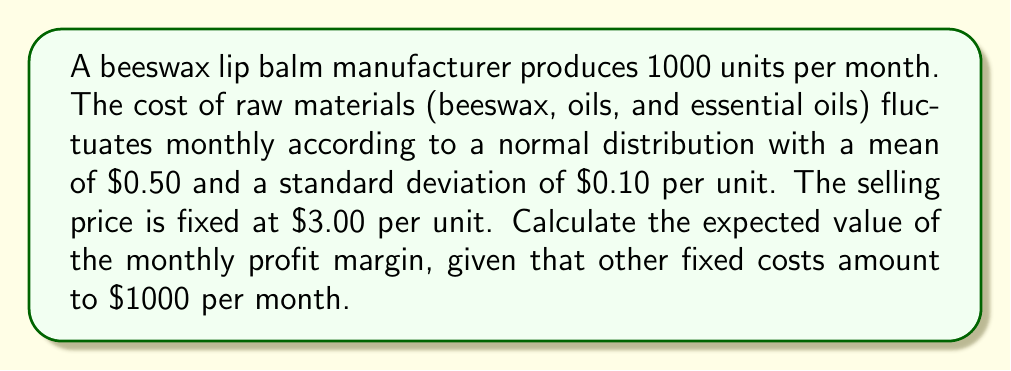Show me your answer to this math problem. Let's approach this step-by-step:

1) First, we need to define our variables:
   Let $X$ be the random variable representing the cost of raw materials per unit.
   $X \sim N(\mu = 0.50, \sigma = 0.10)$

2) The profit per unit is the selling price minus the cost of raw materials:
   Profit per unit = $3.00 - X$

3) For 1000 units, the total profit before fixed costs is:
   Total profit before fixed costs = $1000(3.00 - X)$

4) Subtracting the fixed costs:
   Total profit = $1000(3.00 - X) - 1000$

5) The expected value of the total profit is:
   $E[\text{Total profit}] = E[1000(3.00 - X) - 1000]$
   $= 1000E[3.00 - X] - 1000$
   $= 1000(3.00 - E[X]) - 1000$

6) We know that $E[X] = \mu = 0.50$, so:
   $E[\text{Total profit}] = 1000(3.00 - 0.50) - 1000$
   $= 1000(2.50) - 1000$
   $= 2500 - 1000$
   $= 1500$

7) The profit margin is the profit divided by the revenue:
   Expected profit margin = $\frac{E[\text{Total profit}]}{\text{Total revenue}}$
   $= \frac{1500}{1000 \times 3.00} = \frac{1500}{3000} = 0.5$

Therefore, the expected value of the monthly profit margin is 0.5 or 50%.
Answer: $0.5$ or $50\%$ 